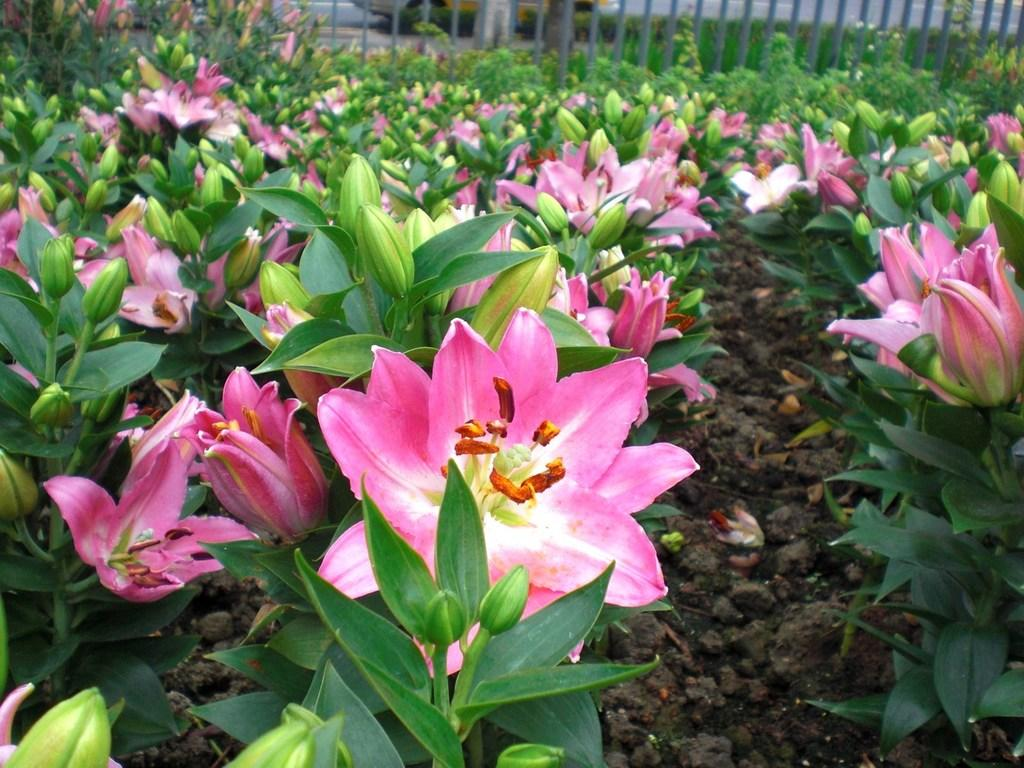What type of outdoor area is depicted in the image? The image contains a garden. What can be found in the garden? There are plants, flowers, and buds in the garden. Is there any structure surrounding the garden? Yes, a fence is visible at the top of the garden. What type of fan can be seen blowing air in the garden? There is no fan present in the garden; it is an outdoor area with plants, flowers, and buds. 